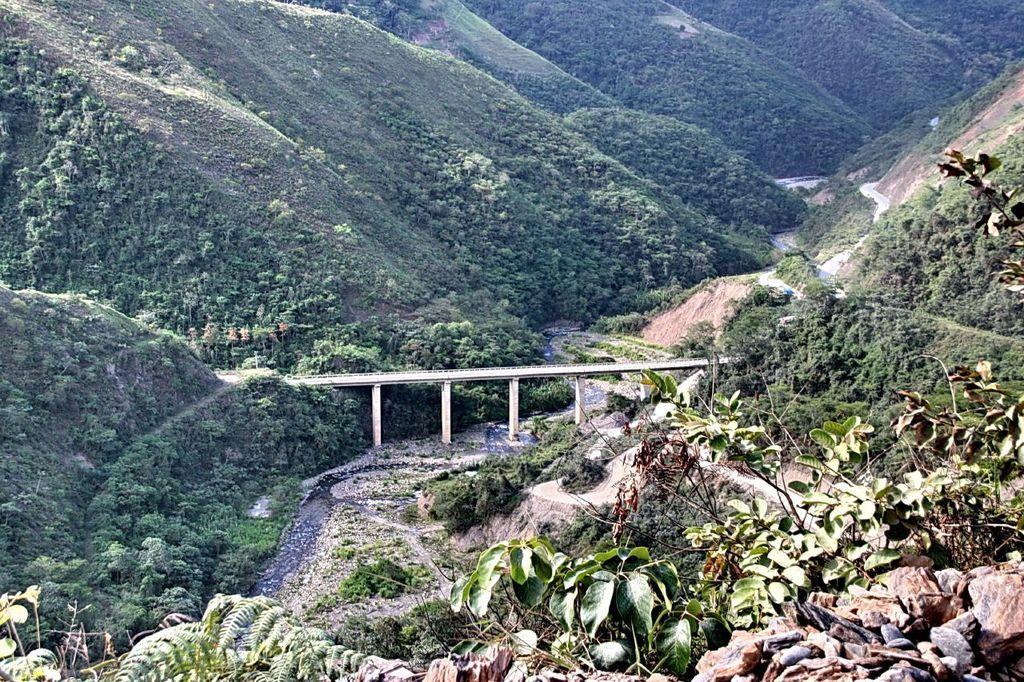What is the main structure in the center of the image? There is a bridge in the center of the image. What type of natural feature can be seen on the right side of the image? There are mountains on the right side of the image. What type of natural feature can be seen on the left side of the image? There are mountains on the left side of the image. What type of vegetation is present in the image? There are trees in the image. Where is the market located in the image? There is no market present in the image. What type of needle can be seen in the image? There is no needle present in the image. 